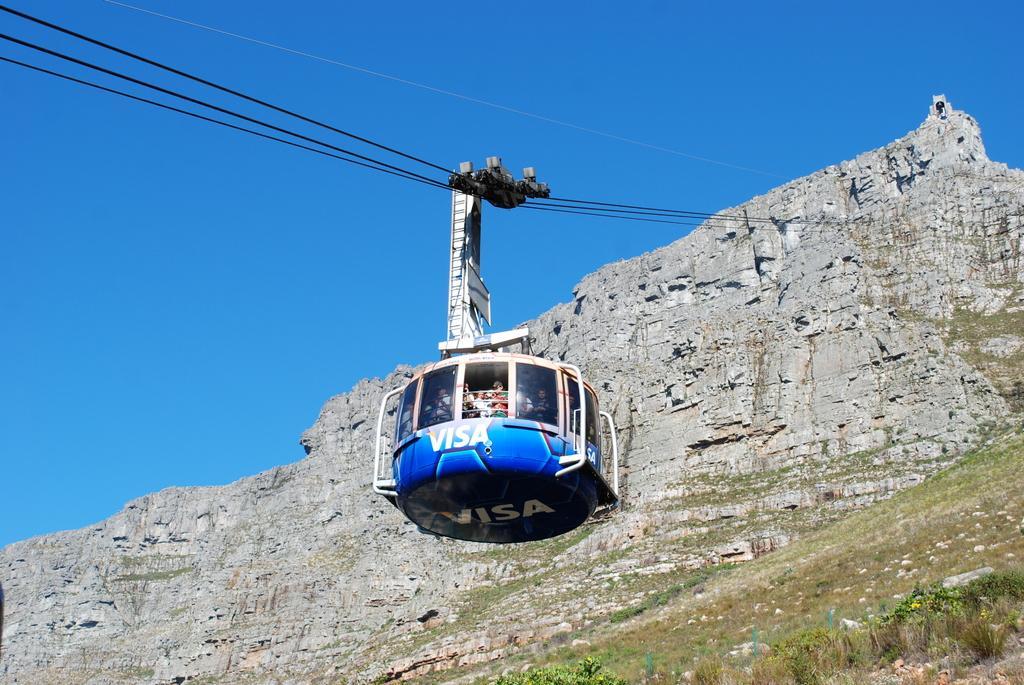In one or two sentences, can you explain what this image depicts? This image consists of a ropeway. In that there are some persons. There is grass at the bottom. 